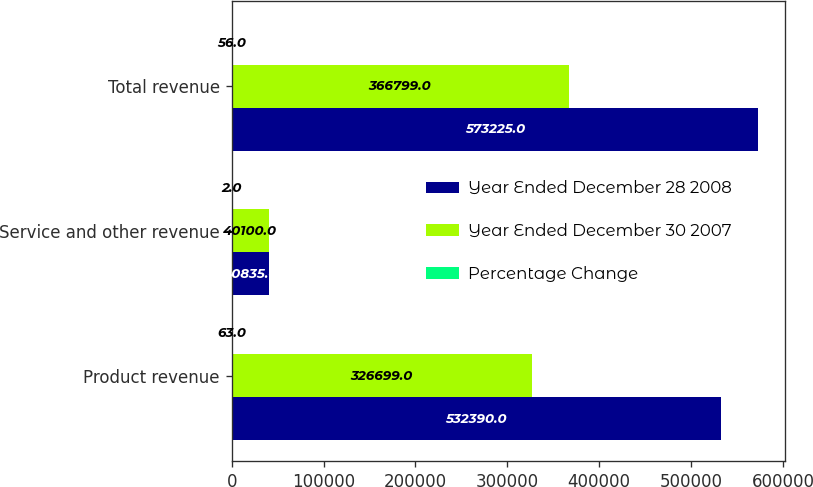Convert chart to OTSL. <chart><loc_0><loc_0><loc_500><loc_500><stacked_bar_chart><ecel><fcel>Product revenue<fcel>Service and other revenue<fcel>Total revenue<nl><fcel>Year Ended December 28 2008<fcel>532390<fcel>40835<fcel>573225<nl><fcel>Year Ended December 30 2007<fcel>326699<fcel>40100<fcel>366799<nl><fcel>Percentage Change<fcel>63<fcel>2<fcel>56<nl></chart> 